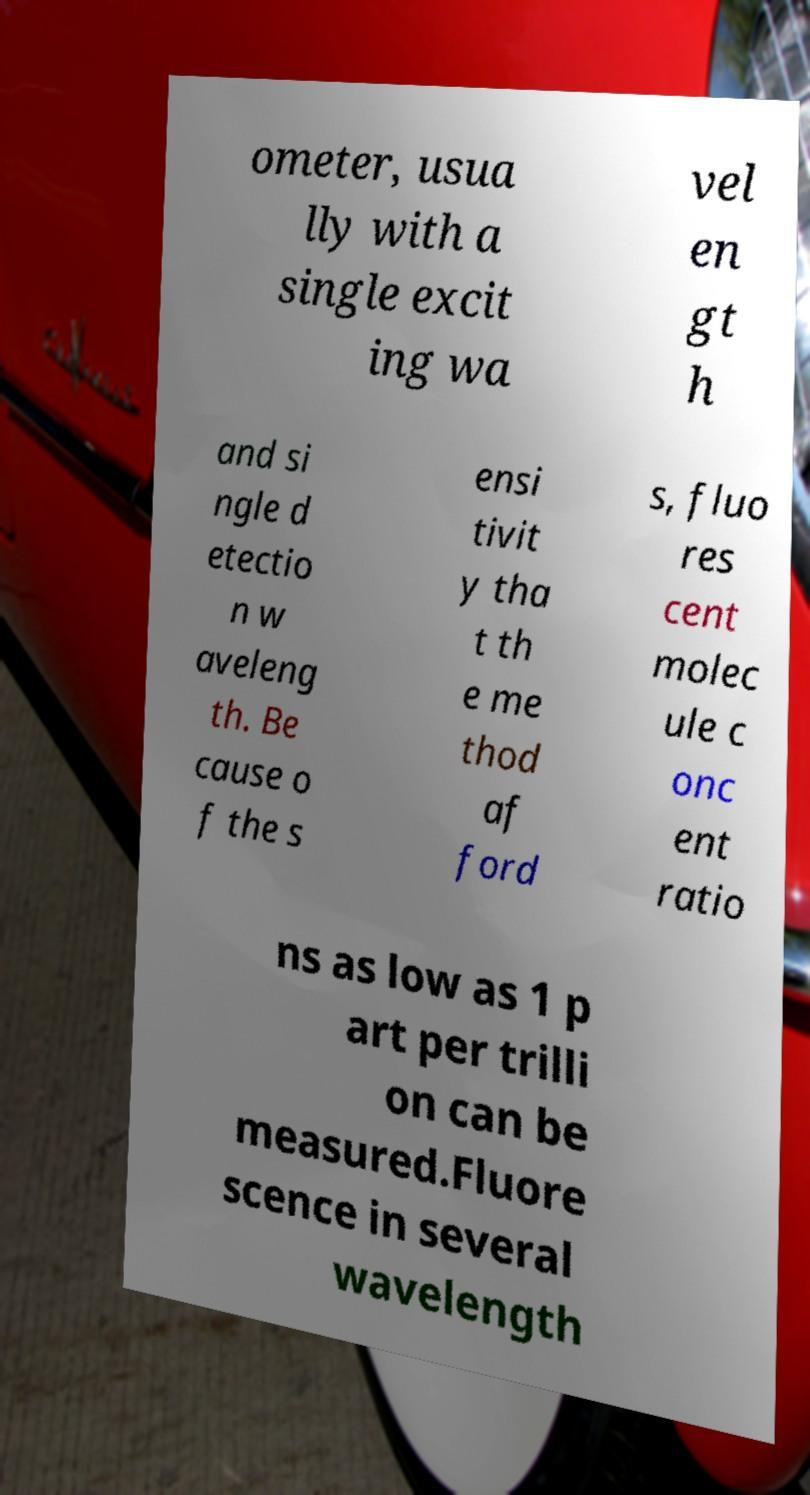Could you assist in decoding the text presented in this image and type it out clearly? ometer, usua lly with a single excit ing wa vel en gt h and si ngle d etectio n w aveleng th. Be cause o f the s ensi tivit y tha t th e me thod af ford s, fluo res cent molec ule c onc ent ratio ns as low as 1 p art per trilli on can be measured.Fluore scence in several wavelength 